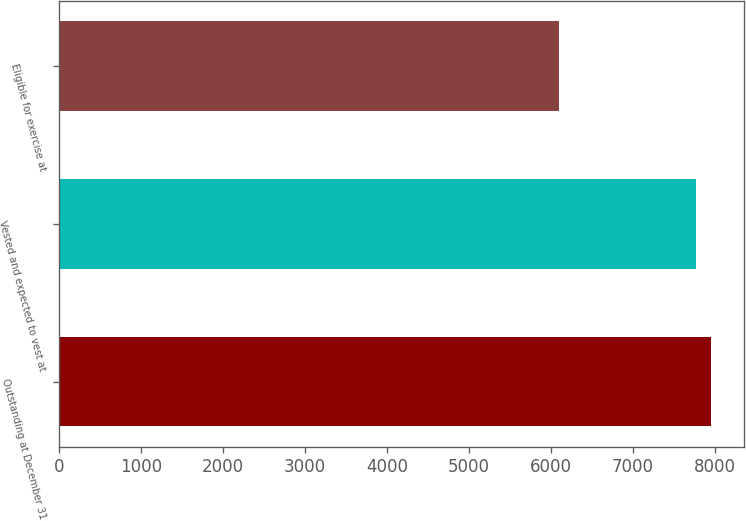Convert chart. <chart><loc_0><loc_0><loc_500><loc_500><bar_chart><fcel>Outstanding at December 31<fcel>Vested and expected to vest at<fcel>Eligible for exercise at<nl><fcel>7953.3<fcel>7775<fcel>6100<nl></chart> 